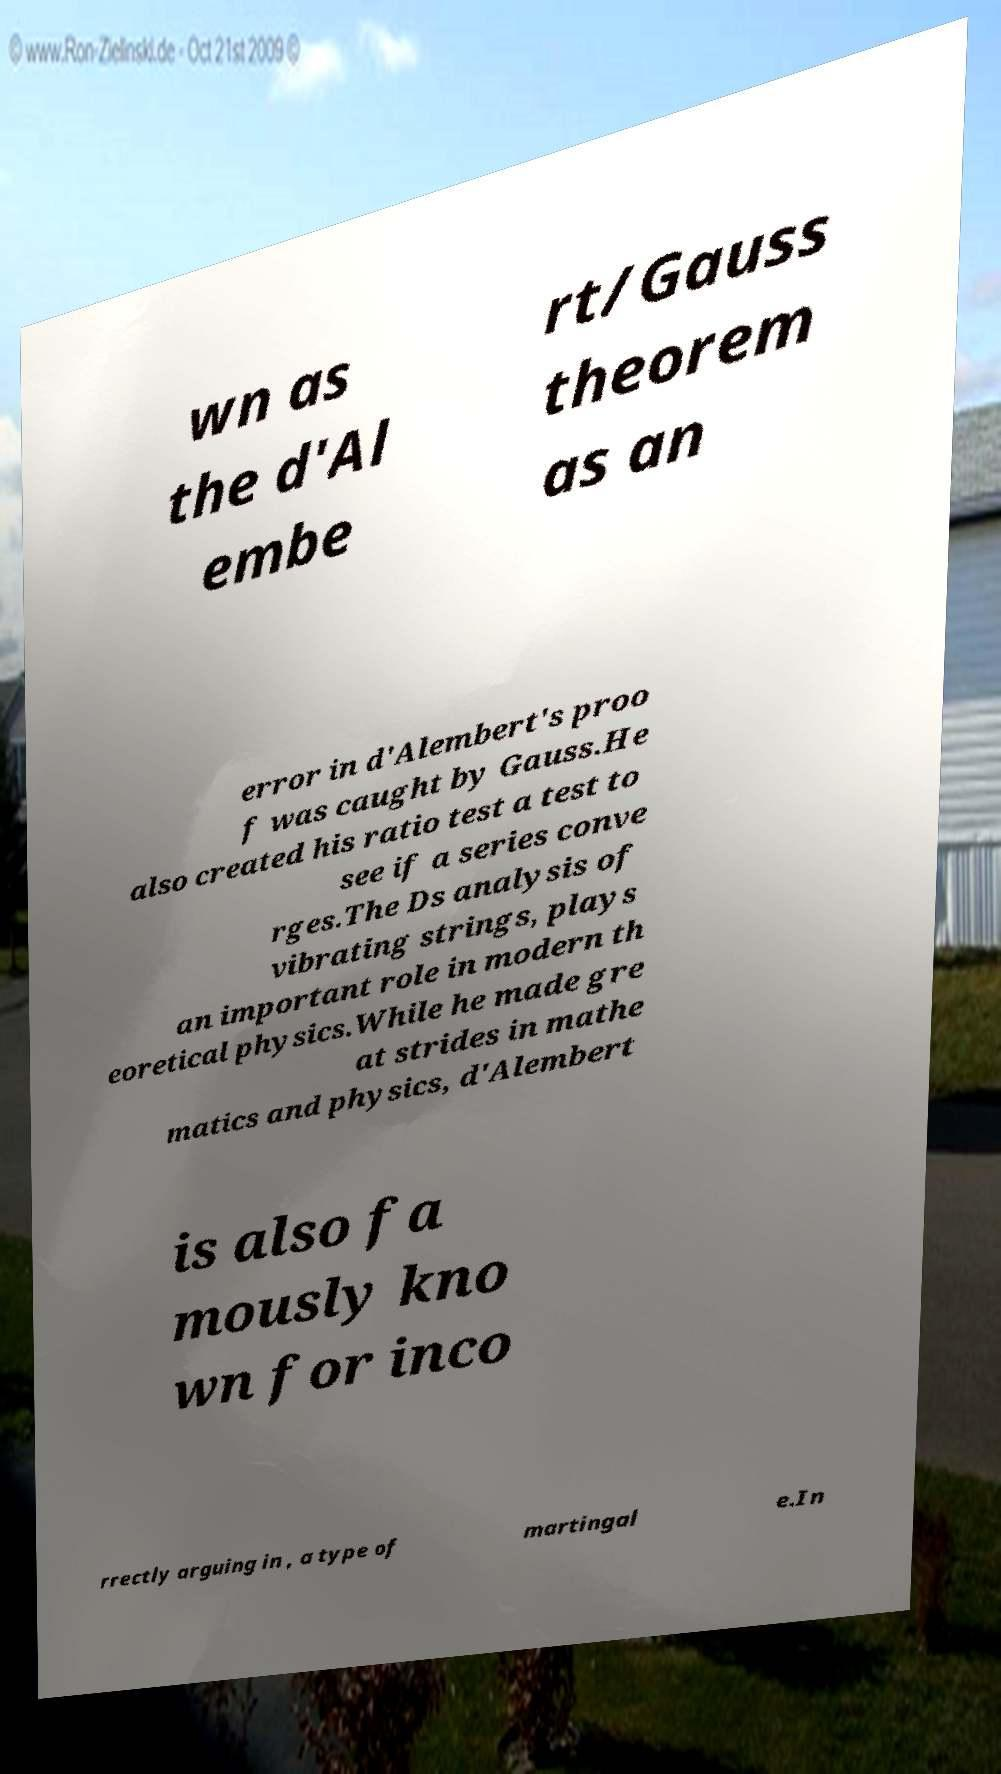Could you extract and type out the text from this image? wn as the d'Al embe rt/Gauss theorem as an error in d'Alembert's proo f was caught by Gauss.He also created his ratio test a test to see if a series conve rges.The Ds analysis of vibrating strings, plays an important role in modern th eoretical physics.While he made gre at strides in mathe matics and physics, d'Alembert is also fa mously kno wn for inco rrectly arguing in , a type of martingal e.In 